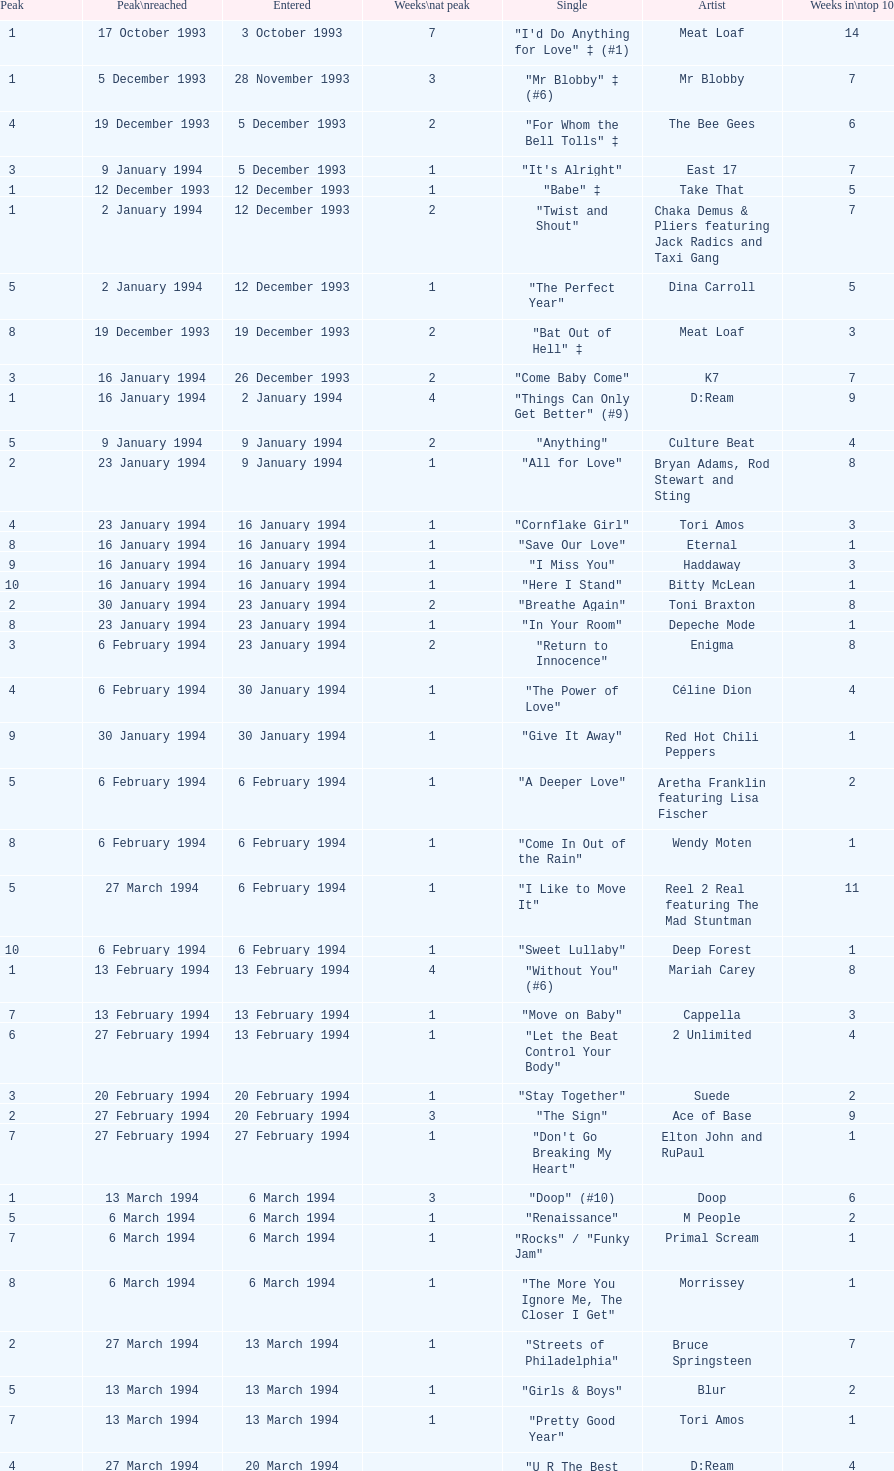Which artist only has its single entered on 2 january 1994? D:Ream. 